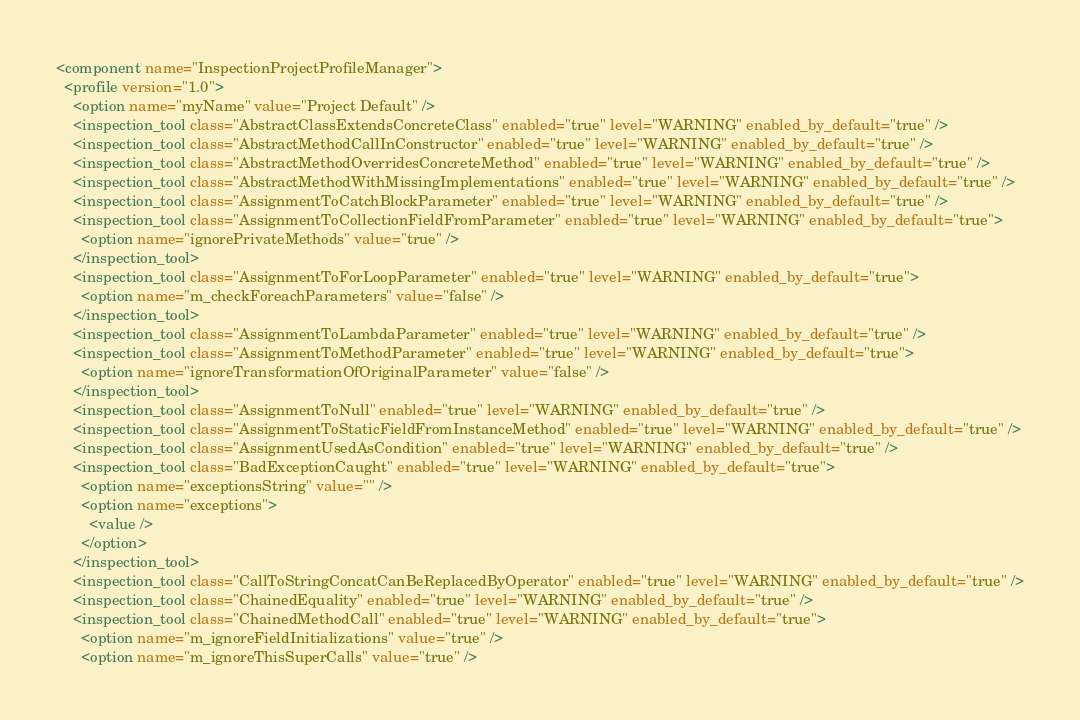<code> <loc_0><loc_0><loc_500><loc_500><_XML_><component name="InspectionProjectProfileManager">
  <profile version="1.0">
    <option name="myName" value="Project Default" />
    <inspection_tool class="AbstractClassExtendsConcreteClass" enabled="true" level="WARNING" enabled_by_default="true" />
    <inspection_tool class="AbstractMethodCallInConstructor" enabled="true" level="WARNING" enabled_by_default="true" />
    <inspection_tool class="AbstractMethodOverridesConcreteMethod" enabled="true" level="WARNING" enabled_by_default="true" />
    <inspection_tool class="AbstractMethodWithMissingImplementations" enabled="true" level="WARNING" enabled_by_default="true" />
    <inspection_tool class="AssignmentToCatchBlockParameter" enabled="true" level="WARNING" enabled_by_default="true" />
    <inspection_tool class="AssignmentToCollectionFieldFromParameter" enabled="true" level="WARNING" enabled_by_default="true">
      <option name="ignorePrivateMethods" value="true" />
    </inspection_tool>
    <inspection_tool class="AssignmentToForLoopParameter" enabled="true" level="WARNING" enabled_by_default="true">
      <option name="m_checkForeachParameters" value="false" />
    </inspection_tool>
    <inspection_tool class="AssignmentToLambdaParameter" enabled="true" level="WARNING" enabled_by_default="true" />
    <inspection_tool class="AssignmentToMethodParameter" enabled="true" level="WARNING" enabled_by_default="true">
      <option name="ignoreTransformationOfOriginalParameter" value="false" />
    </inspection_tool>
    <inspection_tool class="AssignmentToNull" enabled="true" level="WARNING" enabled_by_default="true" />
    <inspection_tool class="AssignmentToStaticFieldFromInstanceMethod" enabled="true" level="WARNING" enabled_by_default="true" />
    <inspection_tool class="AssignmentUsedAsCondition" enabled="true" level="WARNING" enabled_by_default="true" />
    <inspection_tool class="BadExceptionCaught" enabled="true" level="WARNING" enabled_by_default="true">
      <option name="exceptionsString" value="" />
      <option name="exceptions">
        <value />
      </option>
    </inspection_tool>
    <inspection_tool class="CallToStringConcatCanBeReplacedByOperator" enabled="true" level="WARNING" enabled_by_default="true" />
    <inspection_tool class="ChainedEquality" enabled="true" level="WARNING" enabled_by_default="true" />
    <inspection_tool class="ChainedMethodCall" enabled="true" level="WARNING" enabled_by_default="true">
      <option name="m_ignoreFieldInitializations" value="true" />
      <option name="m_ignoreThisSuperCalls" value="true" /></code> 